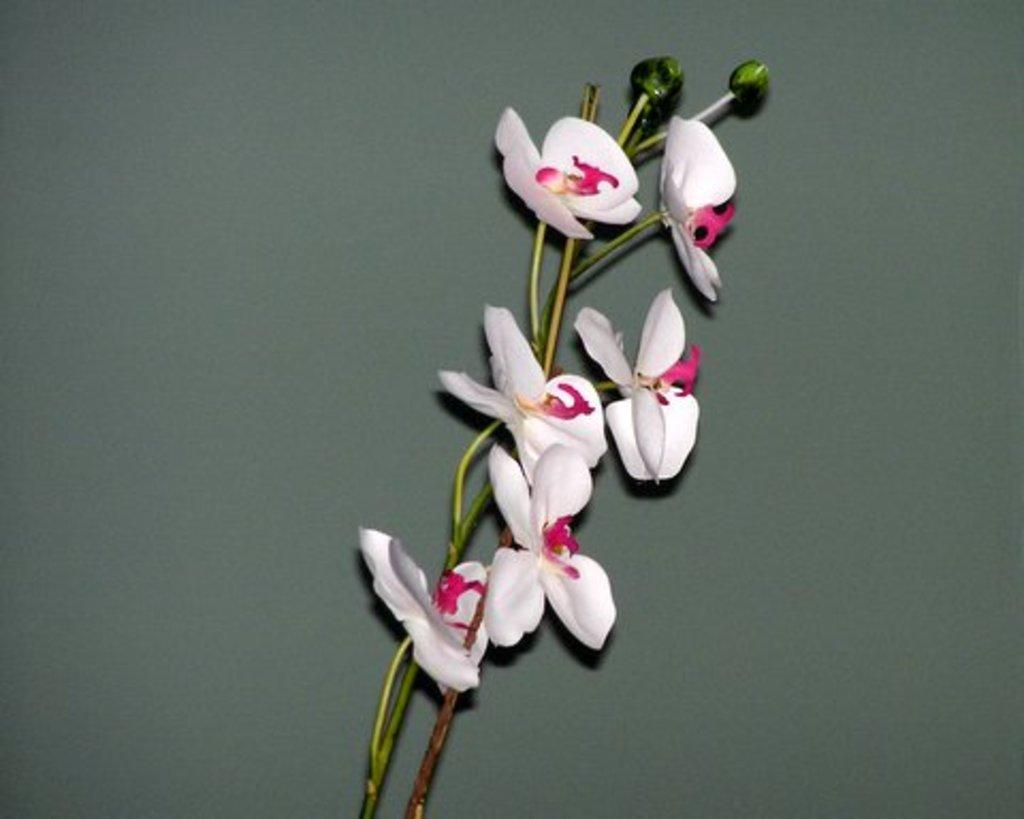What type of flowers can be seen in the image? There are white flowers in the image. Where are the flowers located? The flowers are on a surface. What type of yoke is being used to carry the flowers in the image? There is no yoke present in the image, and the flowers are not being carried. 